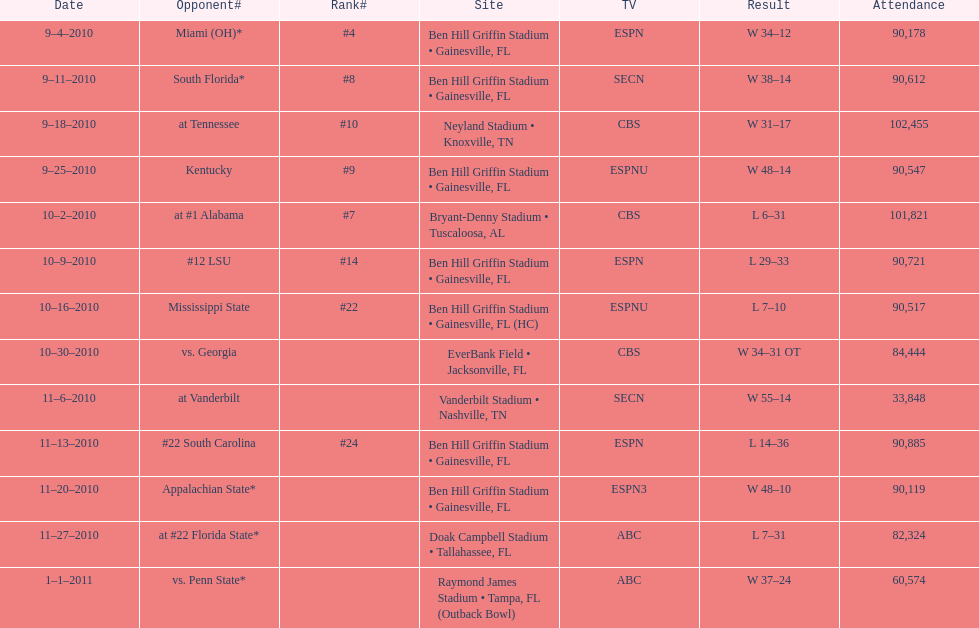In how many contests did the university of florida secure a victory with at least a 10-point margin? 7. 